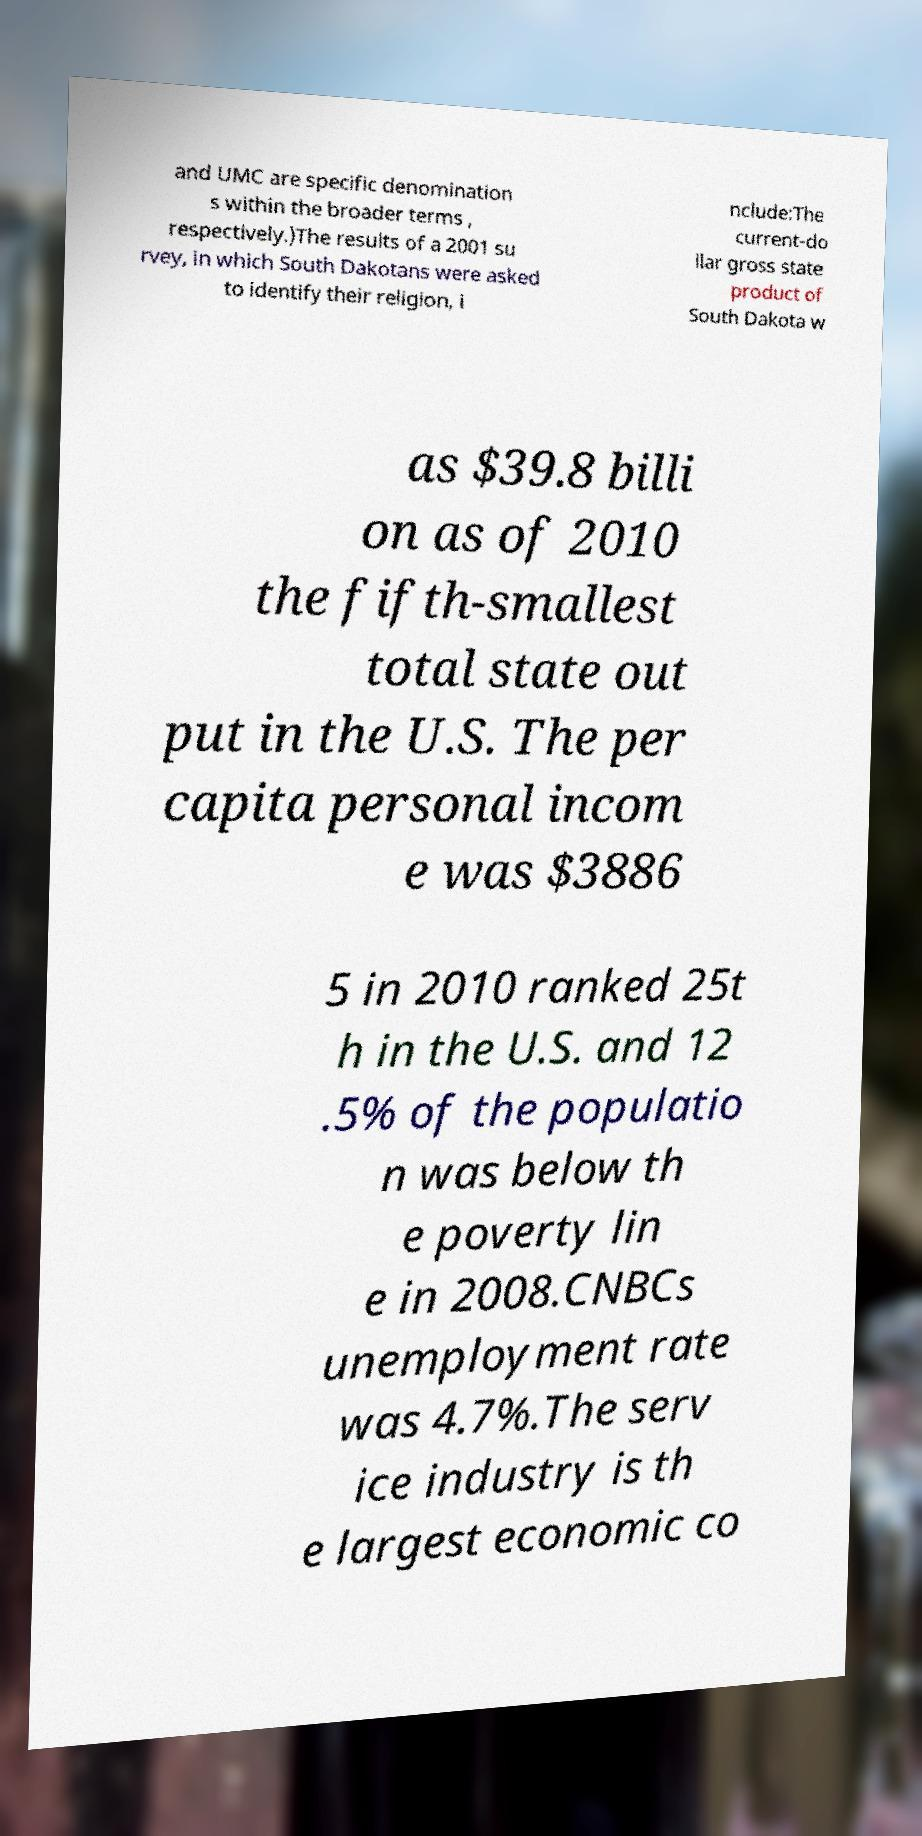Could you extract and type out the text from this image? and UMC are specific denomination s within the broader terms , respectively.)The results of a 2001 su rvey, in which South Dakotans were asked to identify their religion, i nclude:The current-do llar gross state product of South Dakota w as $39.8 billi on as of 2010 the fifth-smallest total state out put in the U.S. The per capita personal incom e was $3886 5 in 2010 ranked 25t h in the U.S. and 12 .5% of the populatio n was below th e poverty lin e in 2008.CNBCs unemployment rate was 4.7%.The serv ice industry is th e largest economic co 